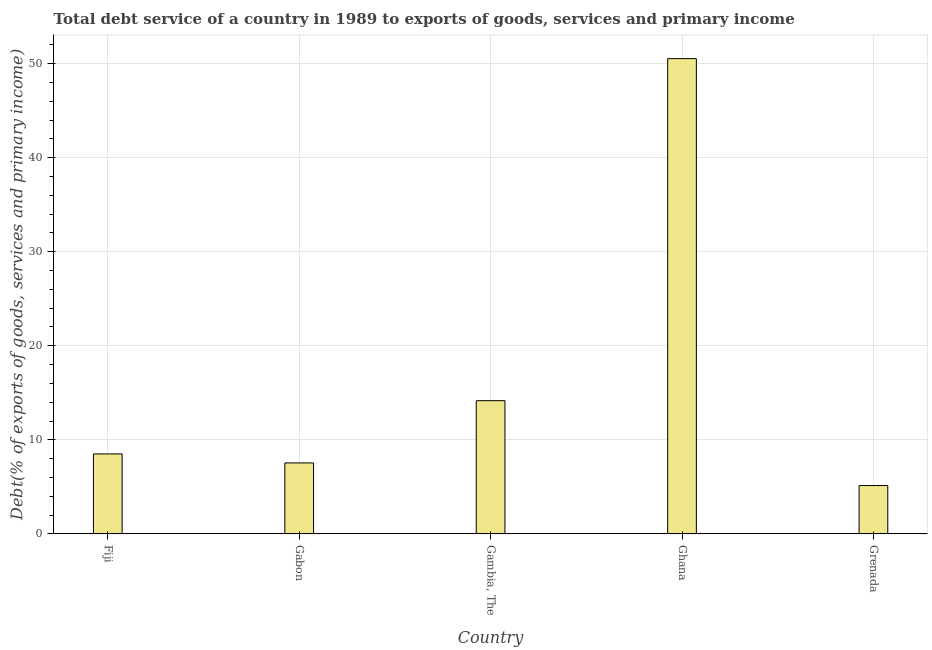Does the graph contain any zero values?
Ensure brevity in your answer.  No. What is the title of the graph?
Offer a very short reply. Total debt service of a country in 1989 to exports of goods, services and primary income. What is the label or title of the X-axis?
Your response must be concise. Country. What is the label or title of the Y-axis?
Offer a terse response. Debt(% of exports of goods, services and primary income). What is the total debt service in Ghana?
Make the answer very short. 50.53. Across all countries, what is the maximum total debt service?
Keep it short and to the point. 50.53. Across all countries, what is the minimum total debt service?
Keep it short and to the point. 5.14. In which country was the total debt service minimum?
Provide a short and direct response. Grenada. What is the sum of the total debt service?
Offer a very short reply. 85.87. What is the difference between the total debt service in Fiji and Grenada?
Offer a terse response. 3.36. What is the average total debt service per country?
Make the answer very short. 17.17. What is the median total debt service?
Your response must be concise. 8.5. What is the ratio of the total debt service in Fiji to that in Grenada?
Offer a very short reply. 1.65. Is the total debt service in Fiji less than that in Gambia, The?
Provide a short and direct response. Yes. Is the difference between the total debt service in Fiji and Gambia, The greater than the difference between any two countries?
Your answer should be very brief. No. What is the difference between the highest and the second highest total debt service?
Give a very brief answer. 36.37. What is the difference between the highest and the lowest total debt service?
Your answer should be very brief. 45.39. In how many countries, is the total debt service greater than the average total debt service taken over all countries?
Offer a very short reply. 1. Are all the bars in the graph horizontal?
Offer a very short reply. No. What is the Debt(% of exports of goods, services and primary income) of Fiji?
Your answer should be very brief. 8.5. What is the Debt(% of exports of goods, services and primary income) in Gabon?
Provide a succinct answer. 7.54. What is the Debt(% of exports of goods, services and primary income) in Gambia, The?
Keep it short and to the point. 14.16. What is the Debt(% of exports of goods, services and primary income) in Ghana?
Provide a succinct answer. 50.53. What is the Debt(% of exports of goods, services and primary income) in Grenada?
Your answer should be very brief. 5.14. What is the difference between the Debt(% of exports of goods, services and primary income) in Fiji and Gabon?
Your response must be concise. 0.96. What is the difference between the Debt(% of exports of goods, services and primary income) in Fiji and Gambia, The?
Your answer should be very brief. -5.66. What is the difference between the Debt(% of exports of goods, services and primary income) in Fiji and Ghana?
Ensure brevity in your answer.  -42.03. What is the difference between the Debt(% of exports of goods, services and primary income) in Fiji and Grenada?
Offer a terse response. 3.36. What is the difference between the Debt(% of exports of goods, services and primary income) in Gabon and Gambia, The?
Provide a short and direct response. -6.62. What is the difference between the Debt(% of exports of goods, services and primary income) in Gabon and Ghana?
Your response must be concise. -42.99. What is the difference between the Debt(% of exports of goods, services and primary income) in Gabon and Grenada?
Provide a succinct answer. 2.41. What is the difference between the Debt(% of exports of goods, services and primary income) in Gambia, The and Ghana?
Provide a short and direct response. -36.37. What is the difference between the Debt(% of exports of goods, services and primary income) in Gambia, The and Grenada?
Keep it short and to the point. 9.02. What is the difference between the Debt(% of exports of goods, services and primary income) in Ghana and Grenada?
Your response must be concise. 45.39. What is the ratio of the Debt(% of exports of goods, services and primary income) in Fiji to that in Gabon?
Provide a short and direct response. 1.13. What is the ratio of the Debt(% of exports of goods, services and primary income) in Fiji to that in Gambia, The?
Offer a very short reply. 0.6. What is the ratio of the Debt(% of exports of goods, services and primary income) in Fiji to that in Ghana?
Your answer should be compact. 0.17. What is the ratio of the Debt(% of exports of goods, services and primary income) in Fiji to that in Grenada?
Provide a short and direct response. 1.65. What is the ratio of the Debt(% of exports of goods, services and primary income) in Gabon to that in Gambia, The?
Keep it short and to the point. 0.53. What is the ratio of the Debt(% of exports of goods, services and primary income) in Gabon to that in Ghana?
Make the answer very short. 0.15. What is the ratio of the Debt(% of exports of goods, services and primary income) in Gabon to that in Grenada?
Keep it short and to the point. 1.47. What is the ratio of the Debt(% of exports of goods, services and primary income) in Gambia, The to that in Ghana?
Your response must be concise. 0.28. What is the ratio of the Debt(% of exports of goods, services and primary income) in Gambia, The to that in Grenada?
Your answer should be very brief. 2.76. What is the ratio of the Debt(% of exports of goods, services and primary income) in Ghana to that in Grenada?
Keep it short and to the point. 9.84. 